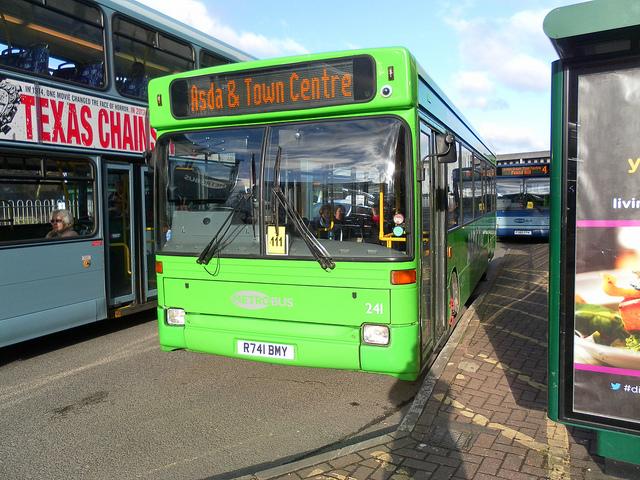What is the color of the bus?
Quick response, please. Green. Is the green bus at a bus stop?
Keep it brief. Yes. Where is the bus going?
Be succinct. Asda & town center. What structure is directly on the other side of the bus's door?
Quick response, please. Bus. 